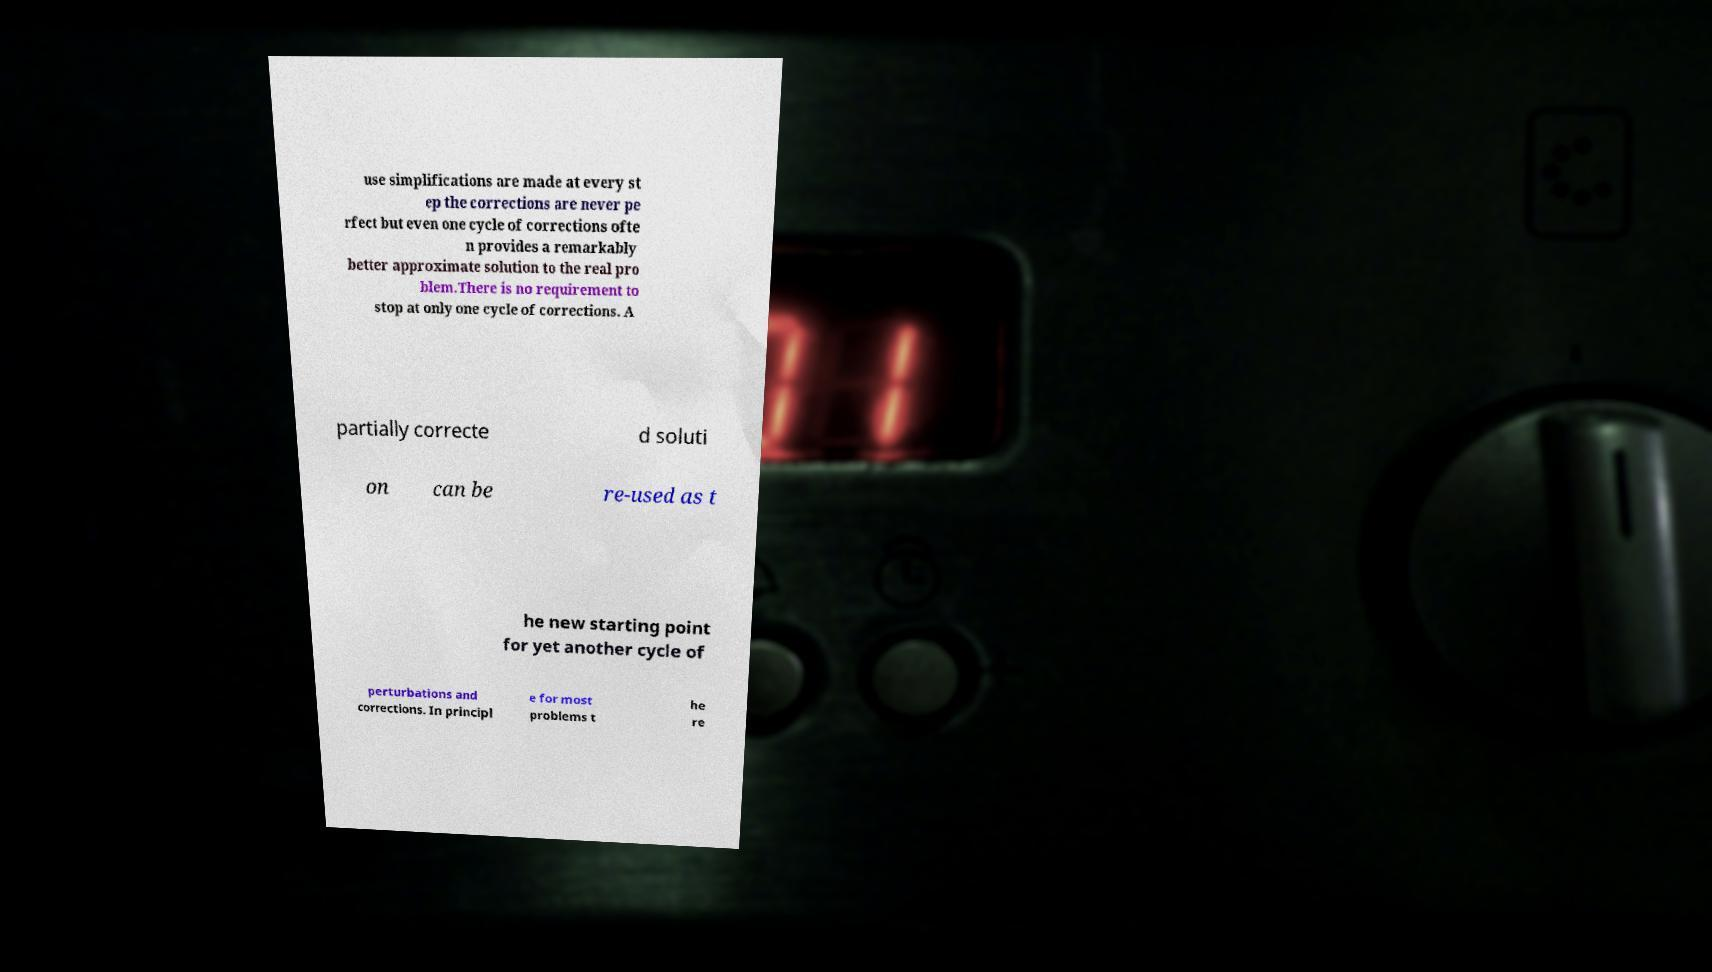I need the written content from this picture converted into text. Can you do that? use simplifications are made at every st ep the corrections are never pe rfect but even one cycle of corrections ofte n provides a remarkably better approximate solution to the real pro blem.There is no requirement to stop at only one cycle of corrections. A partially correcte d soluti on can be re-used as t he new starting point for yet another cycle of perturbations and corrections. In principl e for most problems t he re 